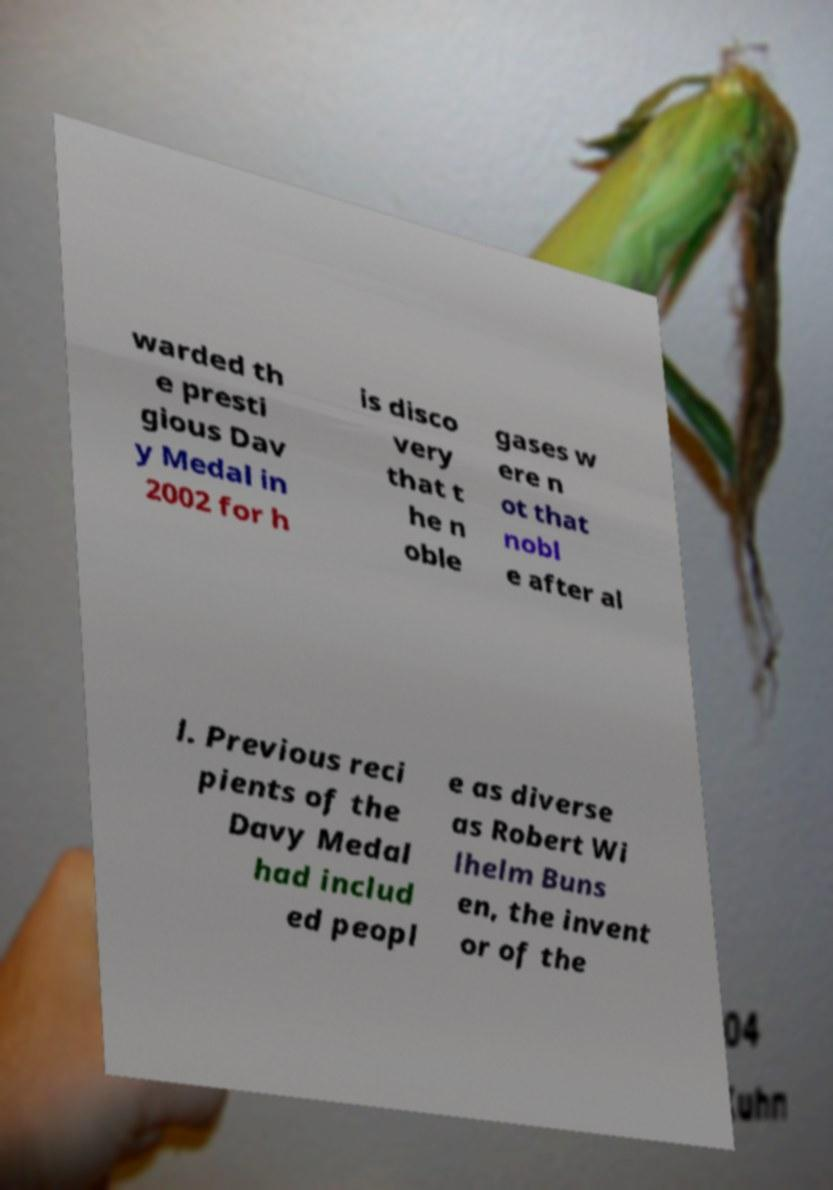Can you accurately transcribe the text from the provided image for me? warded th e presti gious Dav y Medal in 2002 for h is disco very that t he n oble gases w ere n ot that nobl e after al l. Previous reci pients of the Davy Medal had includ ed peopl e as diverse as Robert Wi lhelm Buns en, the invent or of the 